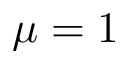Convert formula to latex. <formula><loc_0><loc_0><loc_500><loc_500>\mu = 1</formula> 